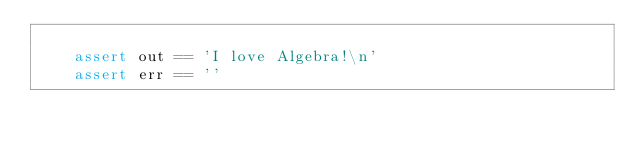Convert code to text. <code><loc_0><loc_0><loc_500><loc_500><_Python_>
    assert out == 'I love Algebra!\n'
    assert err == ''
</code> 